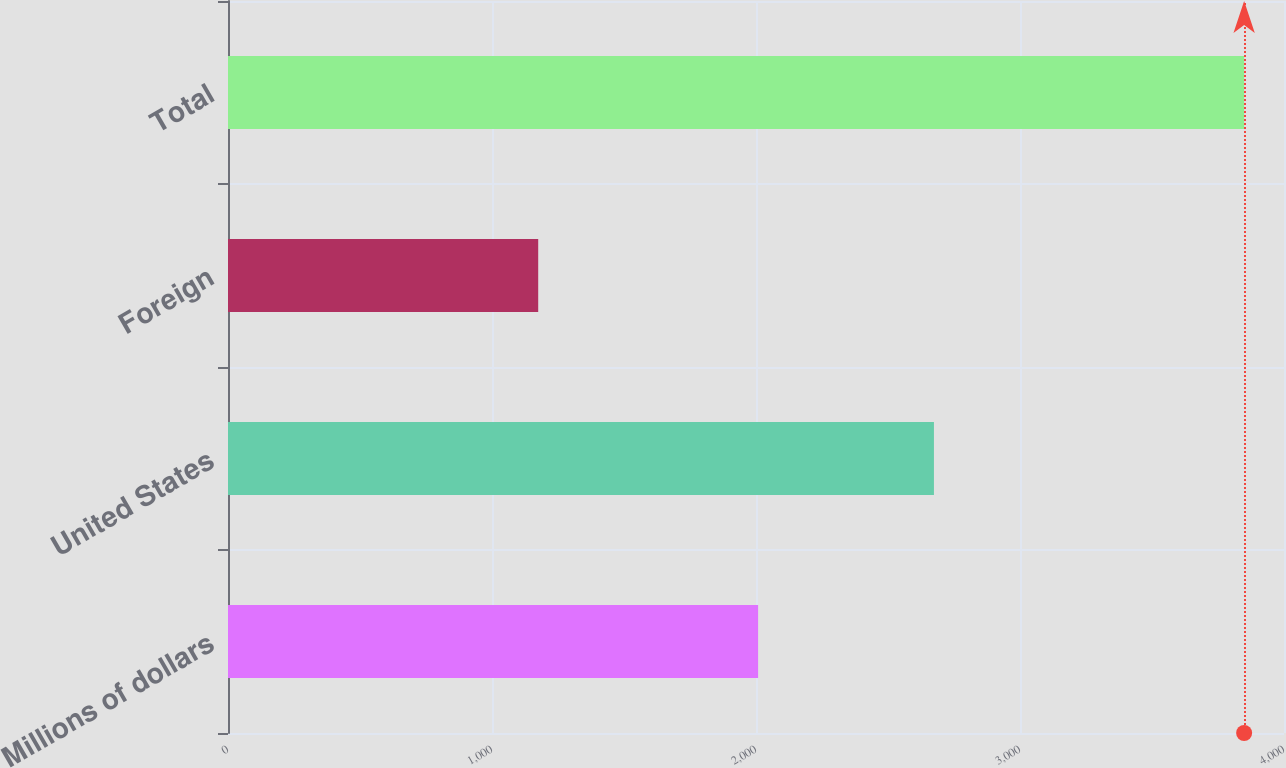Convert chart. <chart><loc_0><loc_0><loc_500><loc_500><bar_chart><fcel>Millions of dollars<fcel>United States<fcel>Foreign<fcel>Total<nl><fcel>2008<fcel>2674<fcel>1175<fcel>3849<nl></chart> 